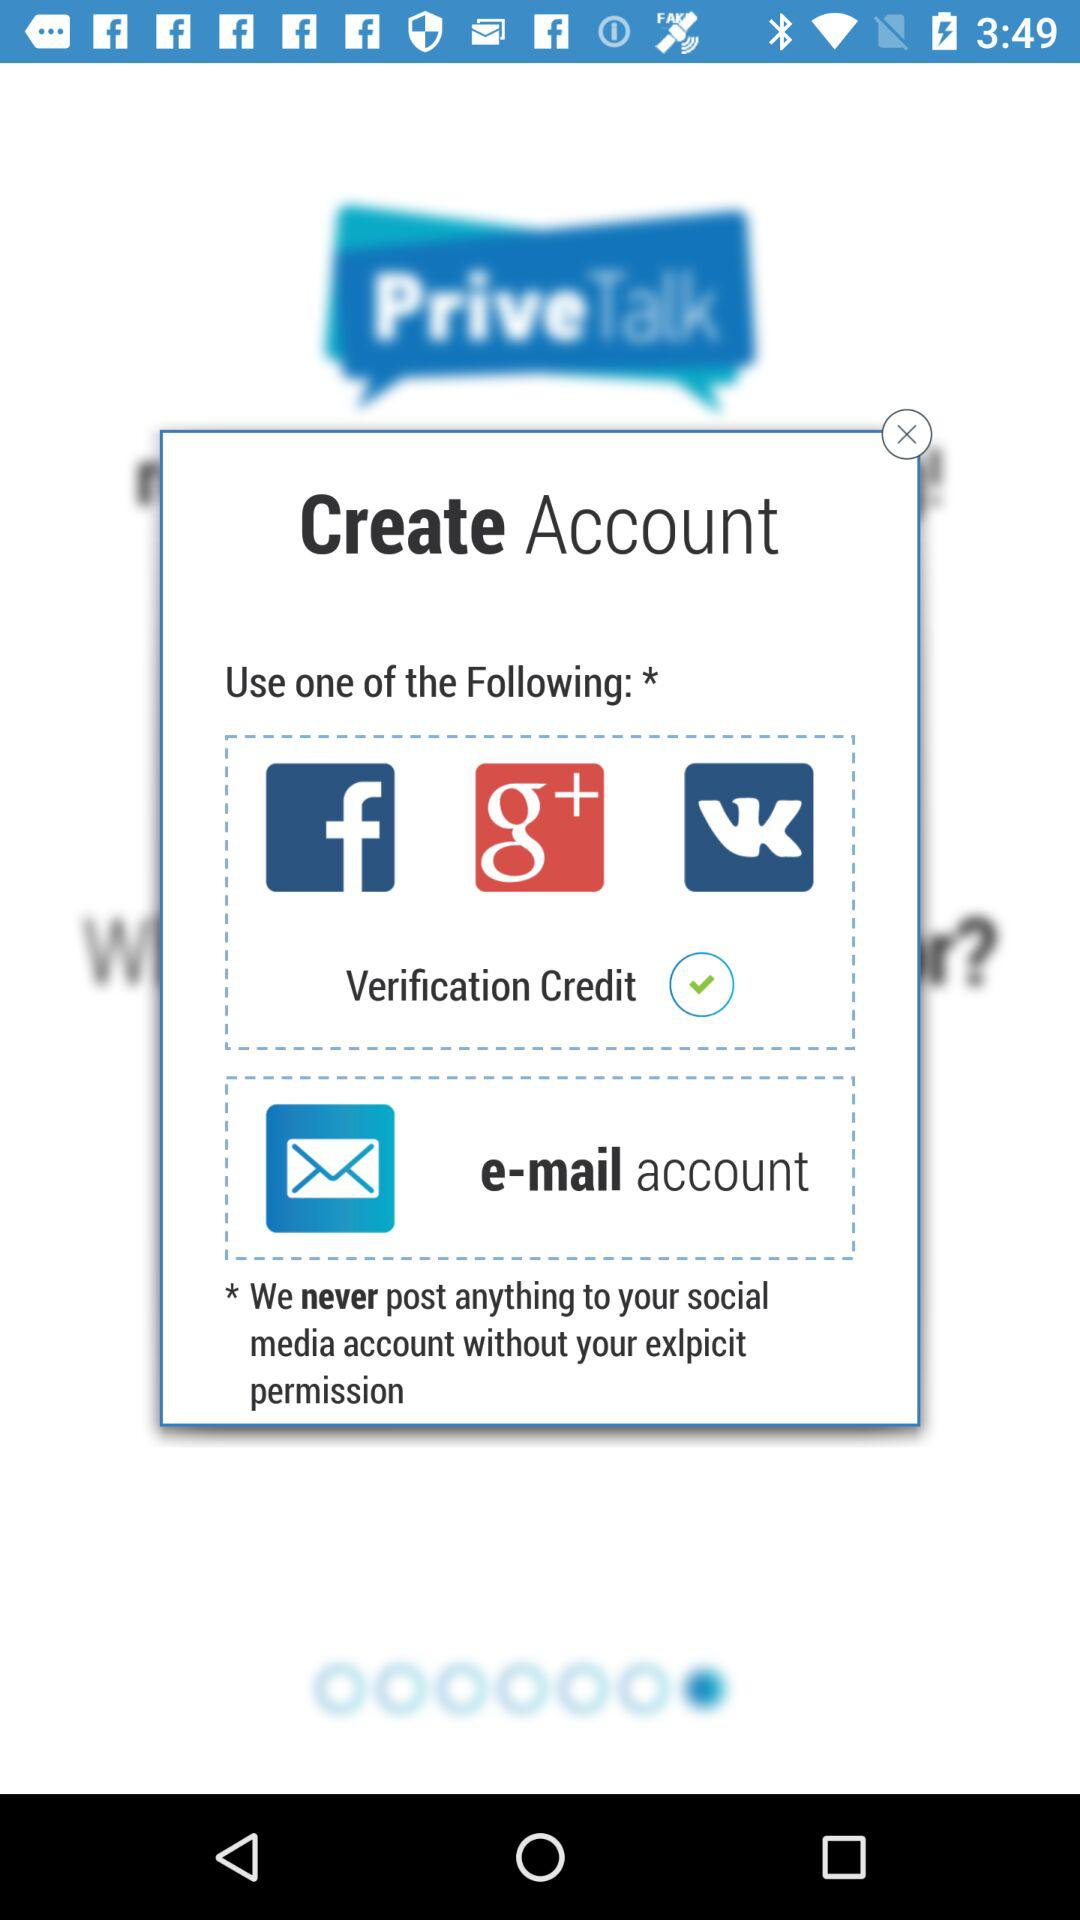How many social media options are there?
Answer the question using a single word or phrase. 3 